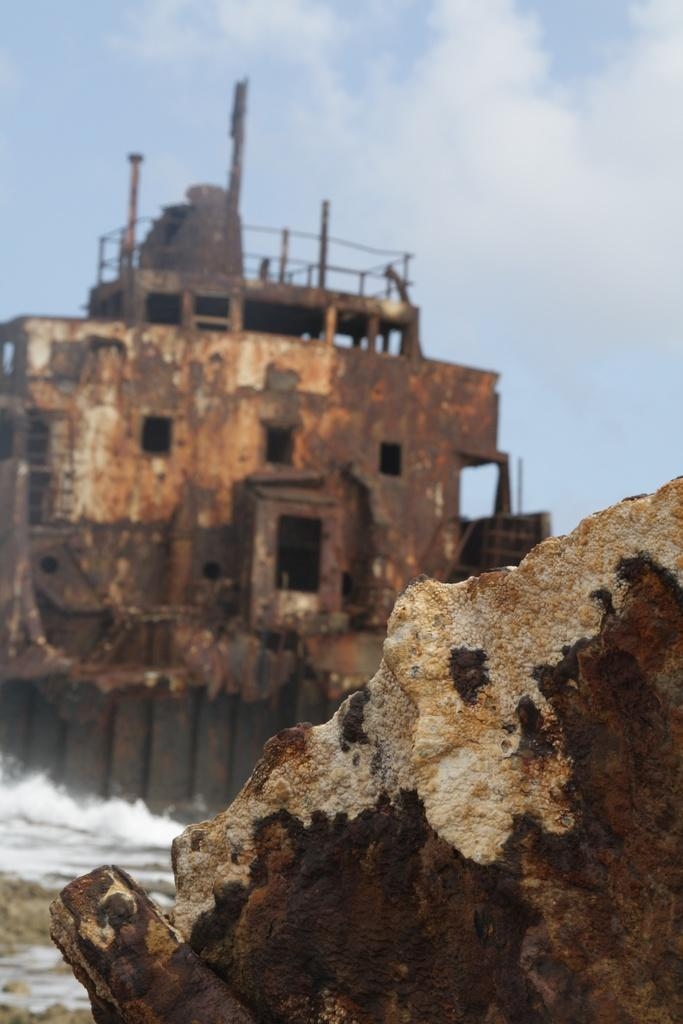What is the main object in the image? There is: There is a rock in the image. What can be seen on the left side of the image? There is water with tides on the left side of the image. What type of structure is present in the image? There is a building in the image. What is visible at the top of the image? The sky is visible at the top of the image. What can be observed in the sky? There are clouds in the sky. What type of history can be seen on the map in the image? There is no map present in the image, so it is not possible to determine any historical information from the image. 